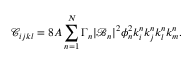Convert formula to latex. <formula><loc_0><loc_0><loc_500><loc_500>\mathcal { C } _ { i j k l } = 8 A \sum _ { n = 1 } ^ { N } \Gamma _ { n } | \mathcal { B } _ { n } | ^ { 2 } \phi _ { n } ^ { 2 } k _ { i } ^ { n } k _ { j } ^ { n } k _ { l } ^ { n } k _ { m } ^ { n } .</formula> 